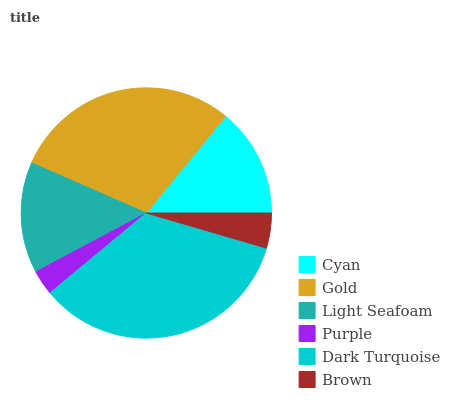Is Purple the minimum?
Answer yes or no. Yes. Is Dark Turquoise the maximum?
Answer yes or no. Yes. Is Gold the minimum?
Answer yes or no. No. Is Gold the maximum?
Answer yes or no. No. Is Gold greater than Cyan?
Answer yes or no. Yes. Is Cyan less than Gold?
Answer yes or no. Yes. Is Cyan greater than Gold?
Answer yes or no. No. Is Gold less than Cyan?
Answer yes or no. No. Is Light Seafoam the high median?
Answer yes or no. Yes. Is Cyan the low median?
Answer yes or no. Yes. Is Brown the high median?
Answer yes or no. No. Is Gold the low median?
Answer yes or no. No. 